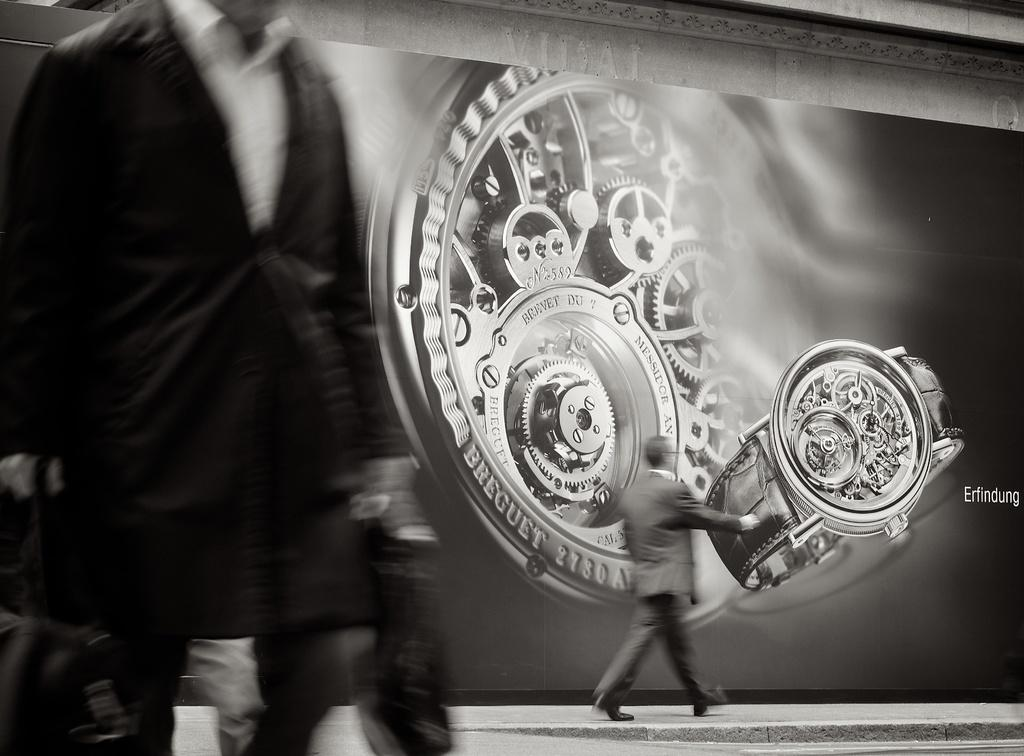<image>
Summarize the visual content of the image. Man in a suit walks past a massive erfindung watch billboard. 